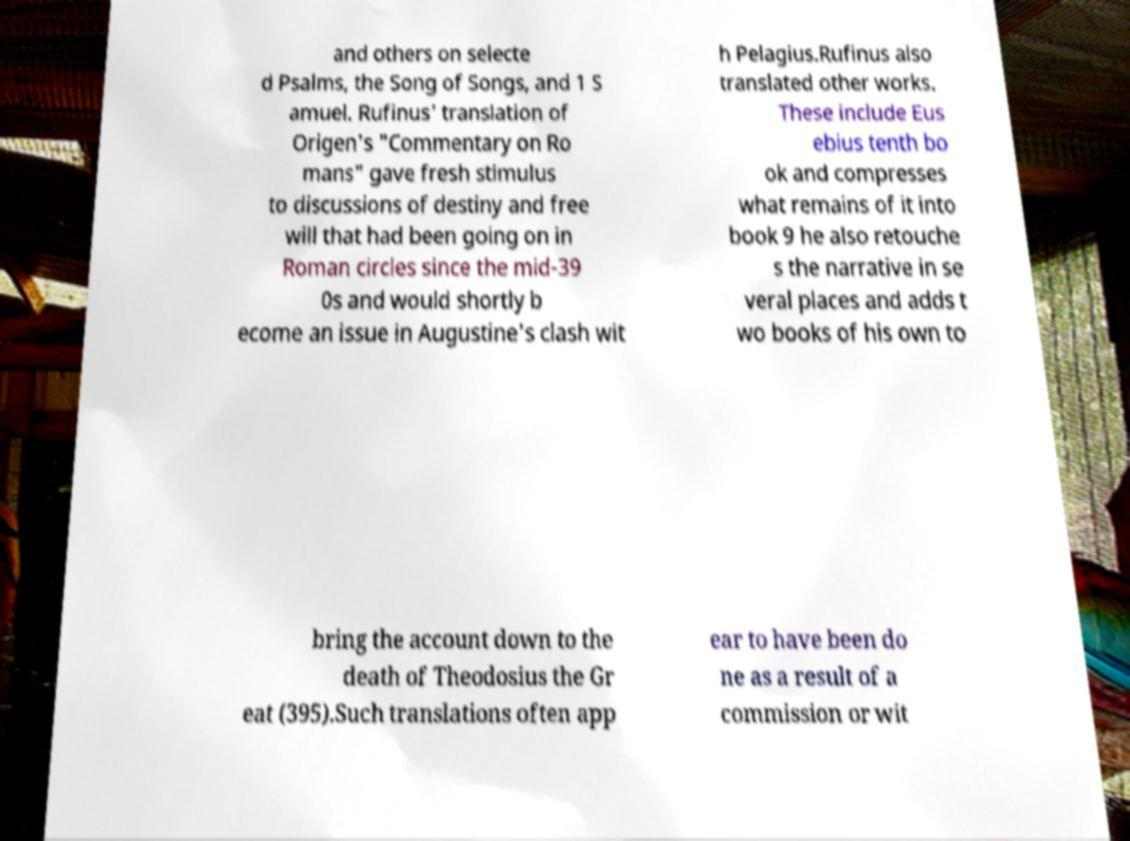For documentation purposes, I need the text within this image transcribed. Could you provide that? and others on selecte d Psalms, the Song of Songs, and 1 S amuel. Rufinus' translation of Origen's "Commentary on Ro mans" gave fresh stimulus to discussions of destiny and free will that had been going on in Roman circles since the mid-39 0s and would shortly b ecome an issue in Augustine's clash wit h Pelagius.Rufinus also translated other works. These include Eus ebius tenth bo ok and compresses what remains of it into book 9 he also retouche s the narrative in se veral places and adds t wo books of his own to bring the account down to the death of Theodosius the Gr eat (395).Such translations often app ear to have been do ne as a result of a commission or wit 